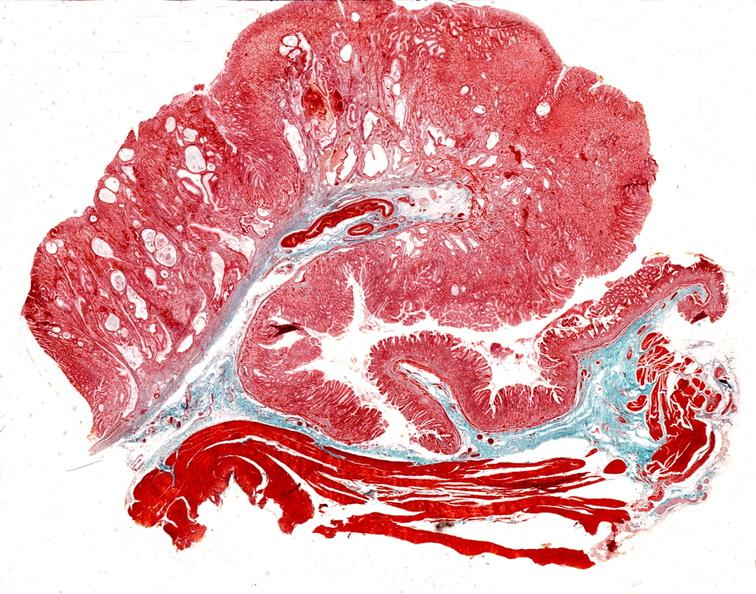what does this image show?
Answer the question using a single word or phrase. Stomach 